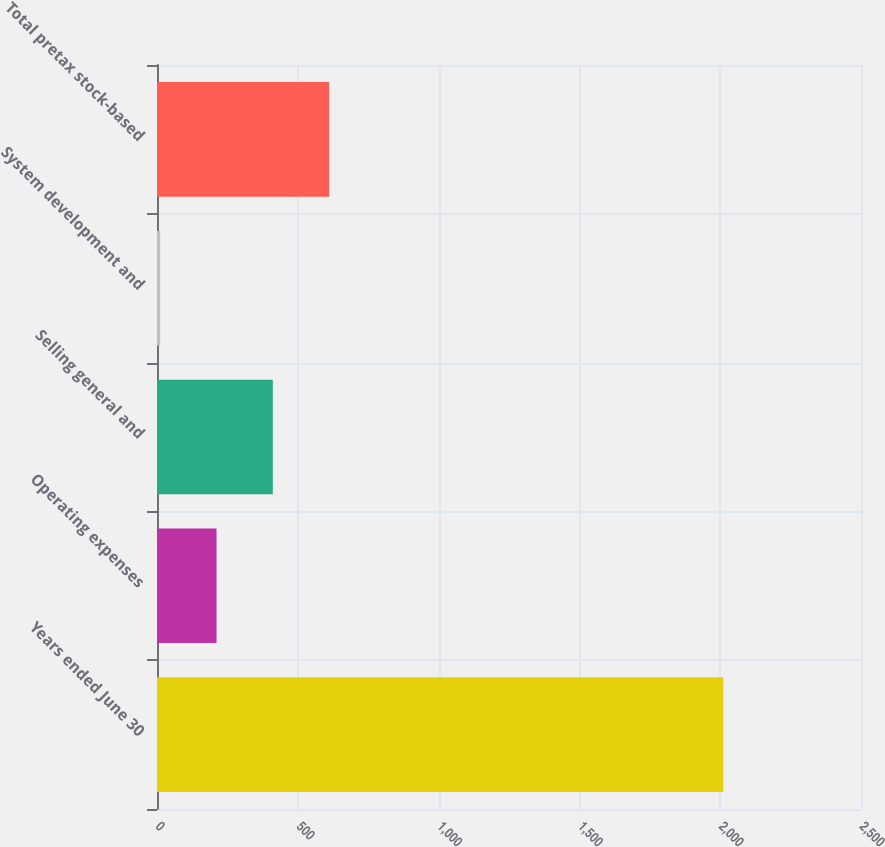Convert chart. <chart><loc_0><loc_0><loc_500><loc_500><bar_chart><fcel>Years ended June 30<fcel>Operating expenses<fcel>Selling general and<fcel>System development and<fcel>Total pretax stock-based<nl><fcel>2011<fcel>211.36<fcel>411.32<fcel>11.4<fcel>611.28<nl></chart> 